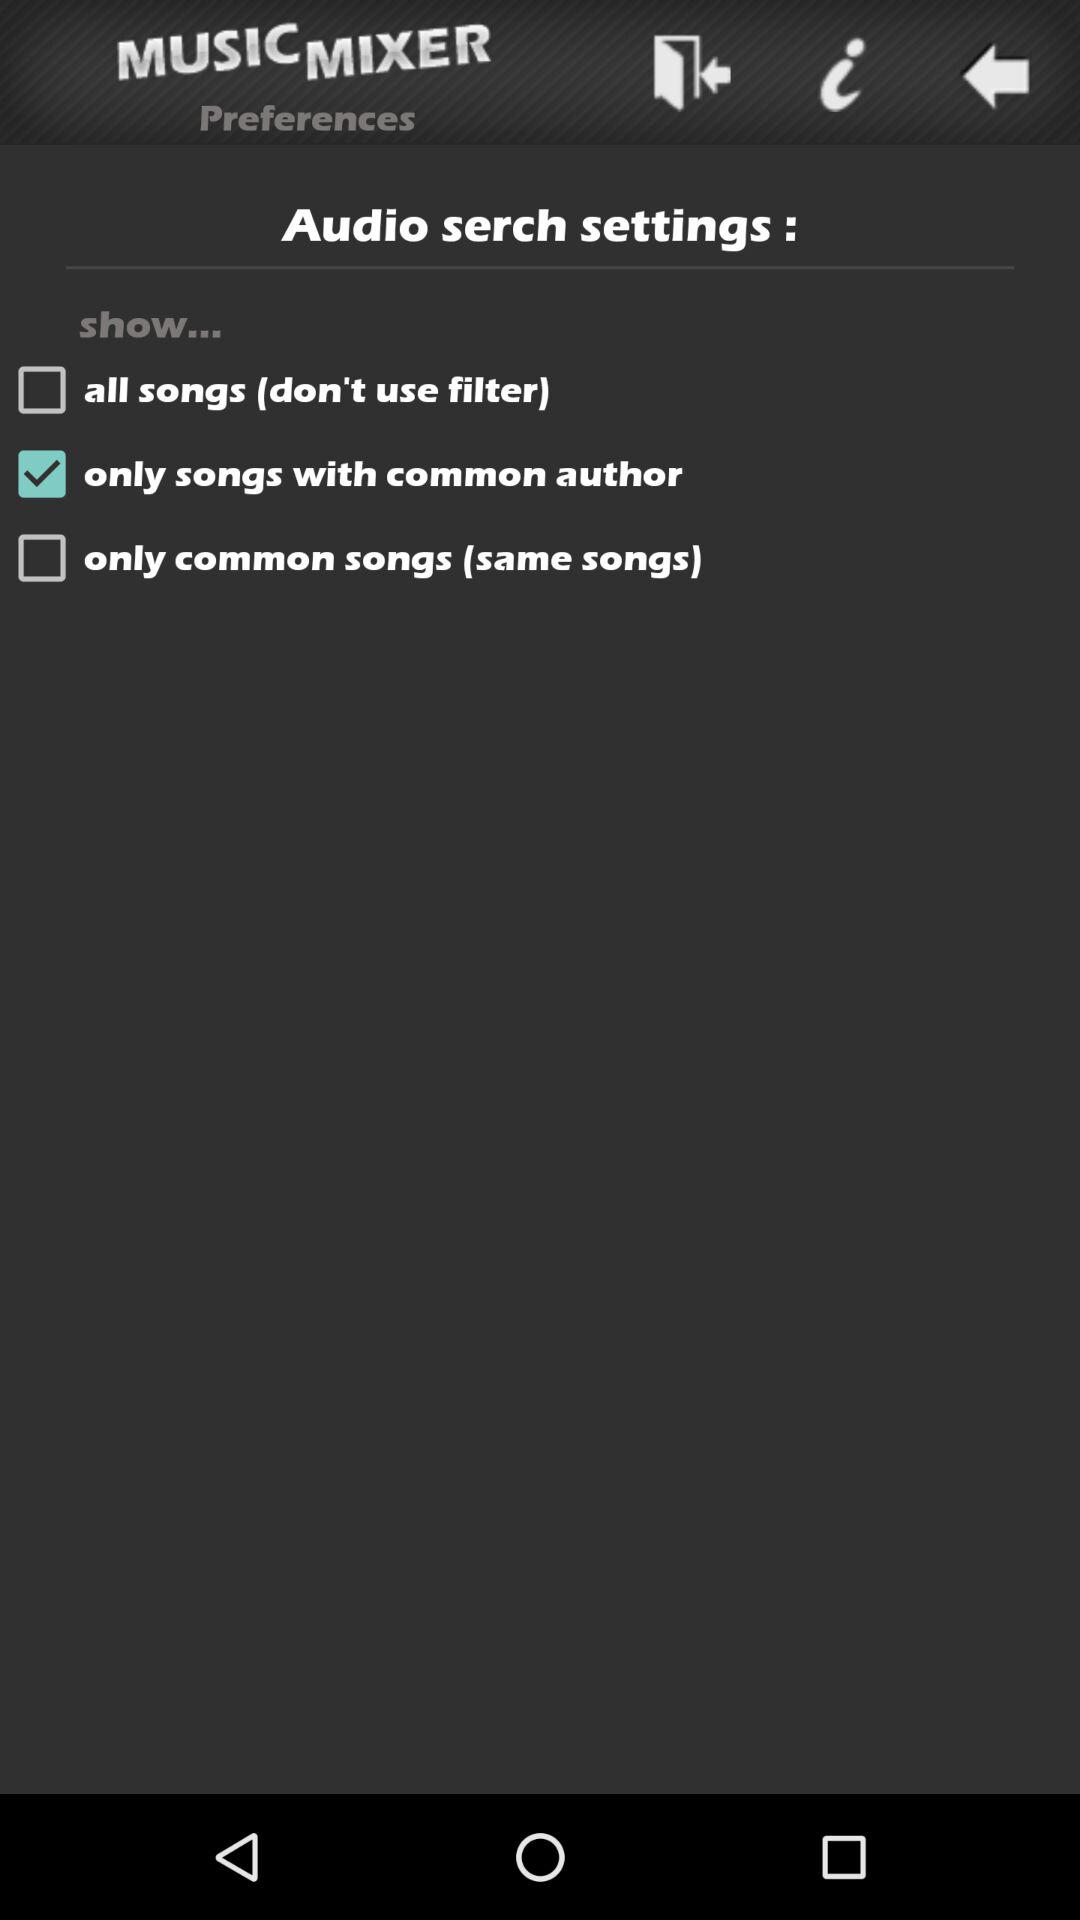How many checkboxes are there that are not checked?
Answer the question using a single word or phrase. 2 